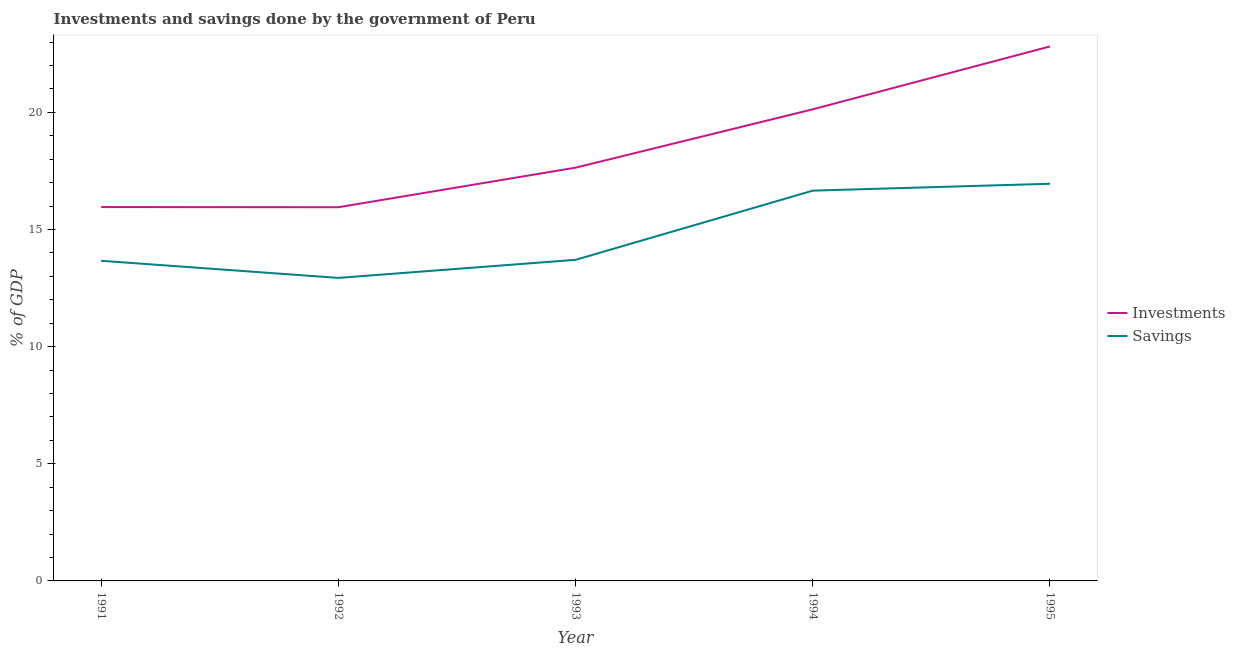What is the investments of government in 1995?
Provide a short and direct response. 22.81. Across all years, what is the maximum investments of government?
Provide a succinct answer. 22.81. Across all years, what is the minimum investments of government?
Offer a terse response. 15.95. In which year was the savings of government maximum?
Keep it short and to the point. 1995. In which year was the investments of government minimum?
Your response must be concise. 1992. What is the total savings of government in the graph?
Offer a terse response. 73.91. What is the difference between the investments of government in 1992 and that in 1995?
Your answer should be compact. -6.86. What is the difference between the savings of government in 1995 and the investments of government in 1993?
Your answer should be very brief. -0.69. What is the average savings of government per year?
Offer a very short reply. 14.78. In the year 1992, what is the difference between the savings of government and investments of government?
Ensure brevity in your answer.  -3.02. In how many years, is the investments of government greater than 3 %?
Offer a very short reply. 5. What is the ratio of the savings of government in 1993 to that in 1995?
Make the answer very short. 0.81. Is the savings of government in 1991 less than that in 1992?
Your response must be concise. No. What is the difference between the highest and the second highest savings of government?
Provide a short and direct response. 0.29. What is the difference between the highest and the lowest savings of government?
Make the answer very short. 4.02. Is the sum of the savings of government in 1992 and 1995 greater than the maximum investments of government across all years?
Your response must be concise. Yes. Does the savings of government monotonically increase over the years?
Keep it short and to the point. No. How many lines are there?
Provide a succinct answer. 2. What is the difference between two consecutive major ticks on the Y-axis?
Offer a very short reply. 5. How many legend labels are there?
Offer a terse response. 2. What is the title of the graph?
Give a very brief answer. Investments and savings done by the government of Peru. Does "Urban agglomerations" appear as one of the legend labels in the graph?
Provide a short and direct response. No. What is the label or title of the Y-axis?
Keep it short and to the point. % of GDP. What is the % of GDP in Investments in 1991?
Make the answer very short. 15.96. What is the % of GDP in Savings in 1991?
Make the answer very short. 13.66. What is the % of GDP in Investments in 1992?
Keep it short and to the point. 15.95. What is the % of GDP in Savings in 1992?
Offer a very short reply. 12.93. What is the % of GDP of Investments in 1993?
Ensure brevity in your answer.  17.64. What is the % of GDP in Savings in 1993?
Provide a succinct answer. 13.7. What is the % of GDP of Investments in 1994?
Keep it short and to the point. 20.13. What is the % of GDP in Savings in 1994?
Your answer should be compact. 16.66. What is the % of GDP of Investments in 1995?
Your answer should be compact. 22.81. What is the % of GDP in Savings in 1995?
Make the answer very short. 16.95. Across all years, what is the maximum % of GDP of Investments?
Ensure brevity in your answer.  22.81. Across all years, what is the maximum % of GDP of Savings?
Your response must be concise. 16.95. Across all years, what is the minimum % of GDP in Investments?
Make the answer very short. 15.95. Across all years, what is the minimum % of GDP of Savings?
Provide a short and direct response. 12.93. What is the total % of GDP in Investments in the graph?
Your answer should be very brief. 92.48. What is the total % of GDP of Savings in the graph?
Your answer should be very brief. 73.91. What is the difference between the % of GDP of Investments in 1991 and that in 1992?
Offer a very short reply. 0.01. What is the difference between the % of GDP in Savings in 1991 and that in 1992?
Ensure brevity in your answer.  0.73. What is the difference between the % of GDP in Investments in 1991 and that in 1993?
Offer a terse response. -1.68. What is the difference between the % of GDP of Savings in 1991 and that in 1993?
Your answer should be very brief. -0.04. What is the difference between the % of GDP of Investments in 1991 and that in 1994?
Offer a very short reply. -4.17. What is the difference between the % of GDP in Savings in 1991 and that in 1994?
Your answer should be compact. -2.99. What is the difference between the % of GDP in Investments in 1991 and that in 1995?
Give a very brief answer. -6.85. What is the difference between the % of GDP in Savings in 1991 and that in 1995?
Offer a very short reply. -3.29. What is the difference between the % of GDP of Investments in 1992 and that in 1993?
Offer a terse response. -1.69. What is the difference between the % of GDP of Savings in 1992 and that in 1993?
Offer a very short reply. -0.77. What is the difference between the % of GDP of Investments in 1992 and that in 1994?
Provide a succinct answer. -4.18. What is the difference between the % of GDP of Savings in 1992 and that in 1994?
Provide a short and direct response. -3.72. What is the difference between the % of GDP of Investments in 1992 and that in 1995?
Provide a short and direct response. -6.86. What is the difference between the % of GDP in Savings in 1992 and that in 1995?
Ensure brevity in your answer.  -4.02. What is the difference between the % of GDP in Investments in 1993 and that in 1994?
Your response must be concise. -2.49. What is the difference between the % of GDP in Savings in 1993 and that in 1994?
Offer a terse response. -2.95. What is the difference between the % of GDP of Investments in 1993 and that in 1995?
Keep it short and to the point. -5.17. What is the difference between the % of GDP in Savings in 1993 and that in 1995?
Ensure brevity in your answer.  -3.25. What is the difference between the % of GDP in Investments in 1994 and that in 1995?
Offer a terse response. -2.68. What is the difference between the % of GDP in Savings in 1994 and that in 1995?
Offer a terse response. -0.29. What is the difference between the % of GDP of Investments in 1991 and the % of GDP of Savings in 1992?
Your answer should be very brief. 3.02. What is the difference between the % of GDP in Investments in 1991 and the % of GDP in Savings in 1993?
Ensure brevity in your answer.  2.25. What is the difference between the % of GDP of Investments in 1991 and the % of GDP of Savings in 1994?
Your answer should be compact. -0.7. What is the difference between the % of GDP in Investments in 1991 and the % of GDP in Savings in 1995?
Keep it short and to the point. -0.99. What is the difference between the % of GDP of Investments in 1992 and the % of GDP of Savings in 1993?
Your answer should be very brief. 2.24. What is the difference between the % of GDP of Investments in 1992 and the % of GDP of Savings in 1994?
Provide a short and direct response. -0.71. What is the difference between the % of GDP in Investments in 1992 and the % of GDP in Savings in 1995?
Offer a very short reply. -1. What is the difference between the % of GDP of Investments in 1993 and the % of GDP of Savings in 1994?
Give a very brief answer. 0.98. What is the difference between the % of GDP of Investments in 1993 and the % of GDP of Savings in 1995?
Keep it short and to the point. 0.69. What is the difference between the % of GDP of Investments in 1994 and the % of GDP of Savings in 1995?
Your response must be concise. 3.18. What is the average % of GDP in Investments per year?
Make the answer very short. 18.5. What is the average % of GDP in Savings per year?
Your response must be concise. 14.78. In the year 1991, what is the difference between the % of GDP of Investments and % of GDP of Savings?
Offer a terse response. 2.29. In the year 1992, what is the difference between the % of GDP of Investments and % of GDP of Savings?
Offer a very short reply. 3.02. In the year 1993, what is the difference between the % of GDP in Investments and % of GDP in Savings?
Your response must be concise. 3.93. In the year 1994, what is the difference between the % of GDP of Investments and % of GDP of Savings?
Offer a terse response. 3.47. In the year 1995, what is the difference between the % of GDP of Investments and % of GDP of Savings?
Make the answer very short. 5.86. What is the ratio of the % of GDP in Savings in 1991 to that in 1992?
Give a very brief answer. 1.06. What is the ratio of the % of GDP in Investments in 1991 to that in 1993?
Provide a succinct answer. 0.9. What is the ratio of the % of GDP in Investments in 1991 to that in 1994?
Make the answer very short. 0.79. What is the ratio of the % of GDP in Savings in 1991 to that in 1994?
Provide a succinct answer. 0.82. What is the ratio of the % of GDP in Investments in 1991 to that in 1995?
Offer a terse response. 0.7. What is the ratio of the % of GDP in Savings in 1991 to that in 1995?
Offer a terse response. 0.81. What is the ratio of the % of GDP in Investments in 1992 to that in 1993?
Offer a terse response. 0.9. What is the ratio of the % of GDP of Savings in 1992 to that in 1993?
Offer a terse response. 0.94. What is the ratio of the % of GDP of Investments in 1992 to that in 1994?
Keep it short and to the point. 0.79. What is the ratio of the % of GDP of Savings in 1992 to that in 1994?
Your answer should be compact. 0.78. What is the ratio of the % of GDP of Investments in 1992 to that in 1995?
Your answer should be compact. 0.7. What is the ratio of the % of GDP of Savings in 1992 to that in 1995?
Give a very brief answer. 0.76. What is the ratio of the % of GDP in Investments in 1993 to that in 1994?
Provide a succinct answer. 0.88. What is the ratio of the % of GDP in Savings in 1993 to that in 1994?
Offer a very short reply. 0.82. What is the ratio of the % of GDP of Investments in 1993 to that in 1995?
Make the answer very short. 0.77. What is the ratio of the % of GDP of Savings in 1993 to that in 1995?
Your response must be concise. 0.81. What is the ratio of the % of GDP of Investments in 1994 to that in 1995?
Your answer should be very brief. 0.88. What is the ratio of the % of GDP in Savings in 1994 to that in 1995?
Your answer should be compact. 0.98. What is the difference between the highest and the second highest % of GDP in Investments?
Offer a terse response. 2.68. What is the difference between the highest and the second highest % of GDP in Savings?
Provide a short and direct response. 0.29. What is the difference between the highest and the lowest % of GDP of Investments?
Provide a succinct answer. 6.86. What is the difference between the highest and the lowest % of GDP of Savings?
Your response must be concise. 4.02. 